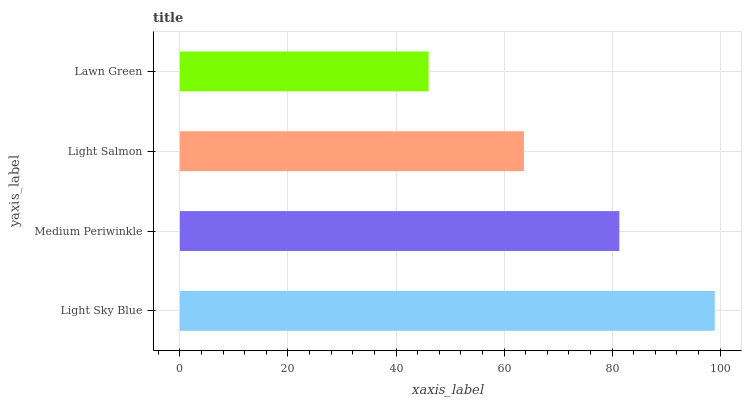Is Lawn Green the minimum?
Answer yes or no. Yes. Is Light Sky Blue the maximum?
Answer yes or no. Yes. Is Medium Periwinkle the minimum?
Answer yes or no. No. Is Medium Periwinkle the maximum?
Answer yes or no. No. Is Light Sky Blue greater than Medium Periwinkle?
Answer yes or no. Yes. Is Medium Periwinkle less than Light Sky Blue?
Answer yes or no. Yes. Is Medium Periwinkle greater than Light Sky Blue?
Answer yes or no. No. Is Light Sky Blue less than Medium Periwinkle?
Answer yes or no. No. Is Medium Periwinkle the high median?
Answer yes or no. Yes. Is Light Salmon the low median?
Answer yes or no. Yes. Is Light Salmon the high median?
Answer yes or no. No. Is Medium Periwinkle the low median?
Answer yes or no. No. 